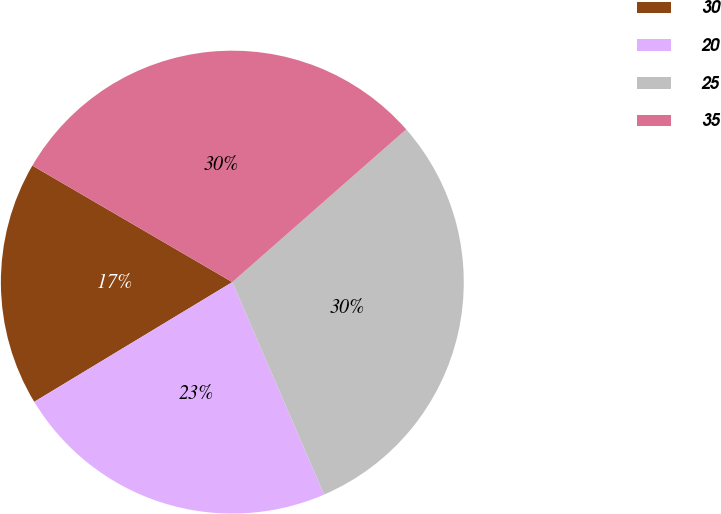Convert chart to OTSL. <chart><loc_0><loc_0><loc_500><loc_500><pie_chart><fcel>30<fcel>20<fcel>25<fcel>35<nl><fcel>17.05%<fcel>22.84%<fcel>29.98%<fcel>30.13%<nl></chart> 